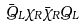Convert formula to latex. <formula><loc_0><loc_0><loc_500><loc_500>\bar { Q } _ { L } \chi _ { R } \bar { \chi } _ { R } Q _ { L }</formula> 